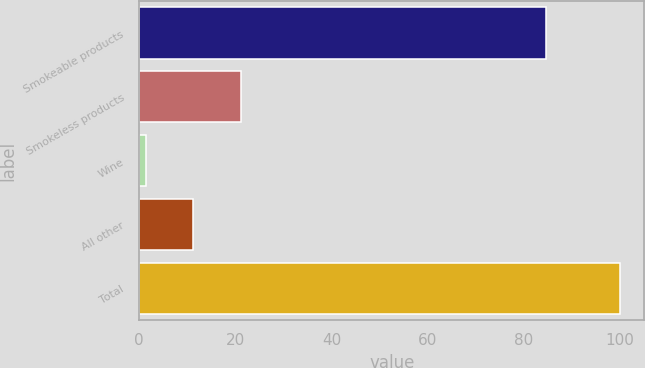Convert chart. <chart><loc_0><loc_0><loc_500><loc_500><bar_chart><fcel>Smokeable products<fcel>Smokeless products<fcel>Wine<fcel>All other<fcel>Total<nl><fcel>84.5<fcel>21.12<fcel>1.4<fcel>11.26<fcel>100<nl></chart> 